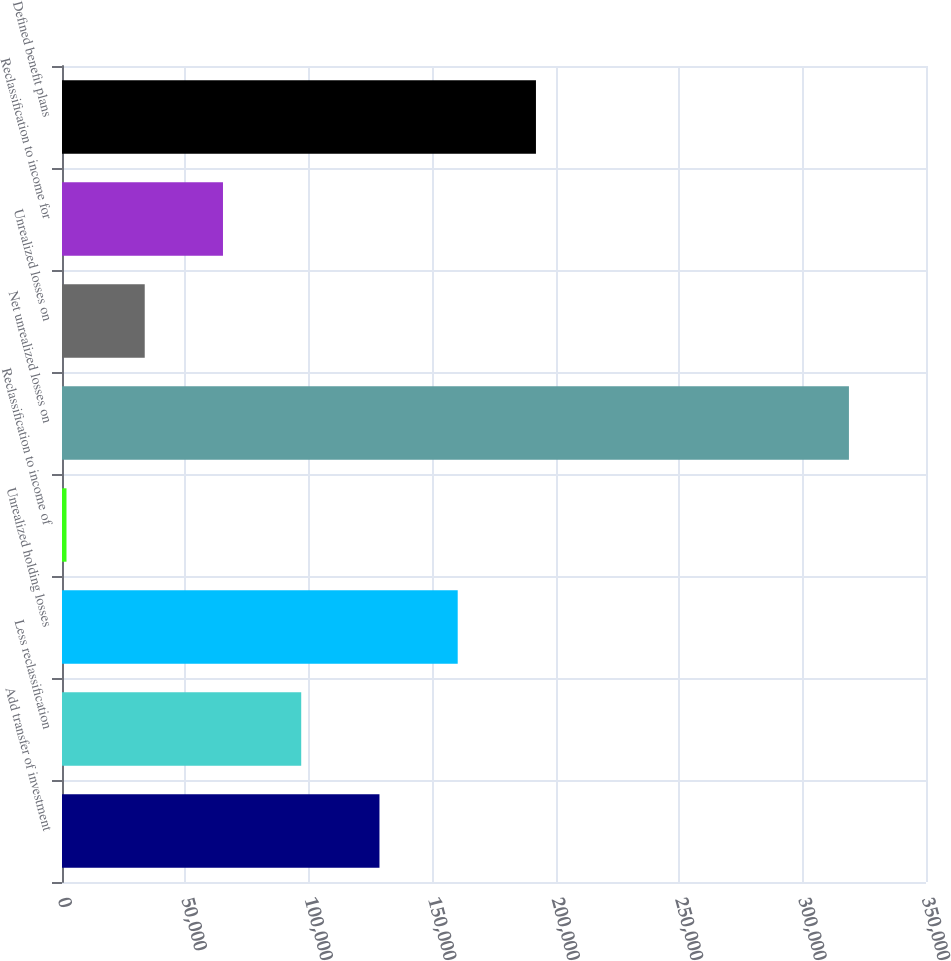Convert chart. <chart><loc_0><loc_0><loc_500><loc_500><bar_chart><fcel>Add transfer of investment<fcel>Less reclassification<fcel>Unrealized holding losses<fcel>Reclassification to income of<fcel>Net unrealized losses on<fcel>Unrealized losses on<fcel>Reclassification to income for<fcel>Defined benefit plans<nl><fcel>128603<fcel>96906.6<fcel>160299<fcel>1818<fcel>318780<fcel>33514.2<fcel>65210.4<fcel>191995<nl></chart> 